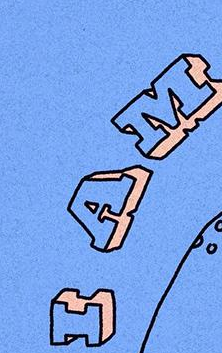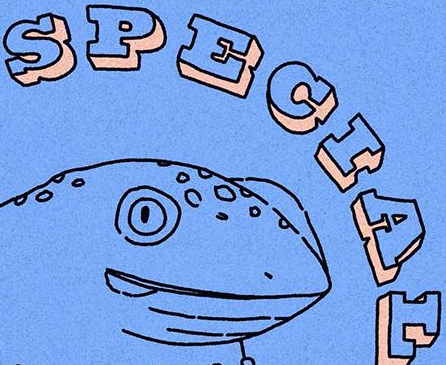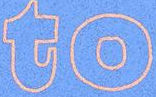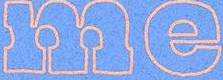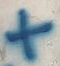Read the text content from these images in order, separated by a semicolon. IAM; SPECIAL; to; me; + 